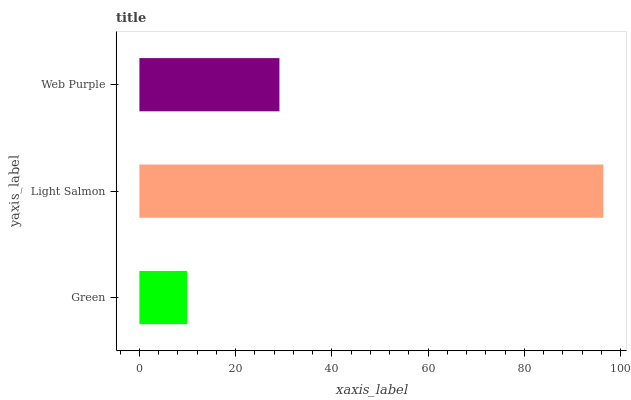Is Green the minimum?
Answer yes or no. Yes. Is Light Salmon the maximum?
Answer yes or no. Yes. Is Web Purple the minimum?
Answer yes or no. No. Is Web Purple the maximum?
Answer yes or no. No. Is Light Salmon greater than Web Purple?
Answer yes or no. Yes. Is Web Purple less than Light Salmon?
Answer yes or no. Yes. Is Web Purple greater than Light Salmon?
Answer yes or no. No. Is Light Salmon less than Web Purple?
Answer yes or no. No. Is Web Purple the high median?
Answer yes or no. Yes. Is Web Purple the low median?
Answer yes or no. Yes. Is Green the high median?
Answer yes or no. No. Is Green the low median?
Answer yes or no. No. 